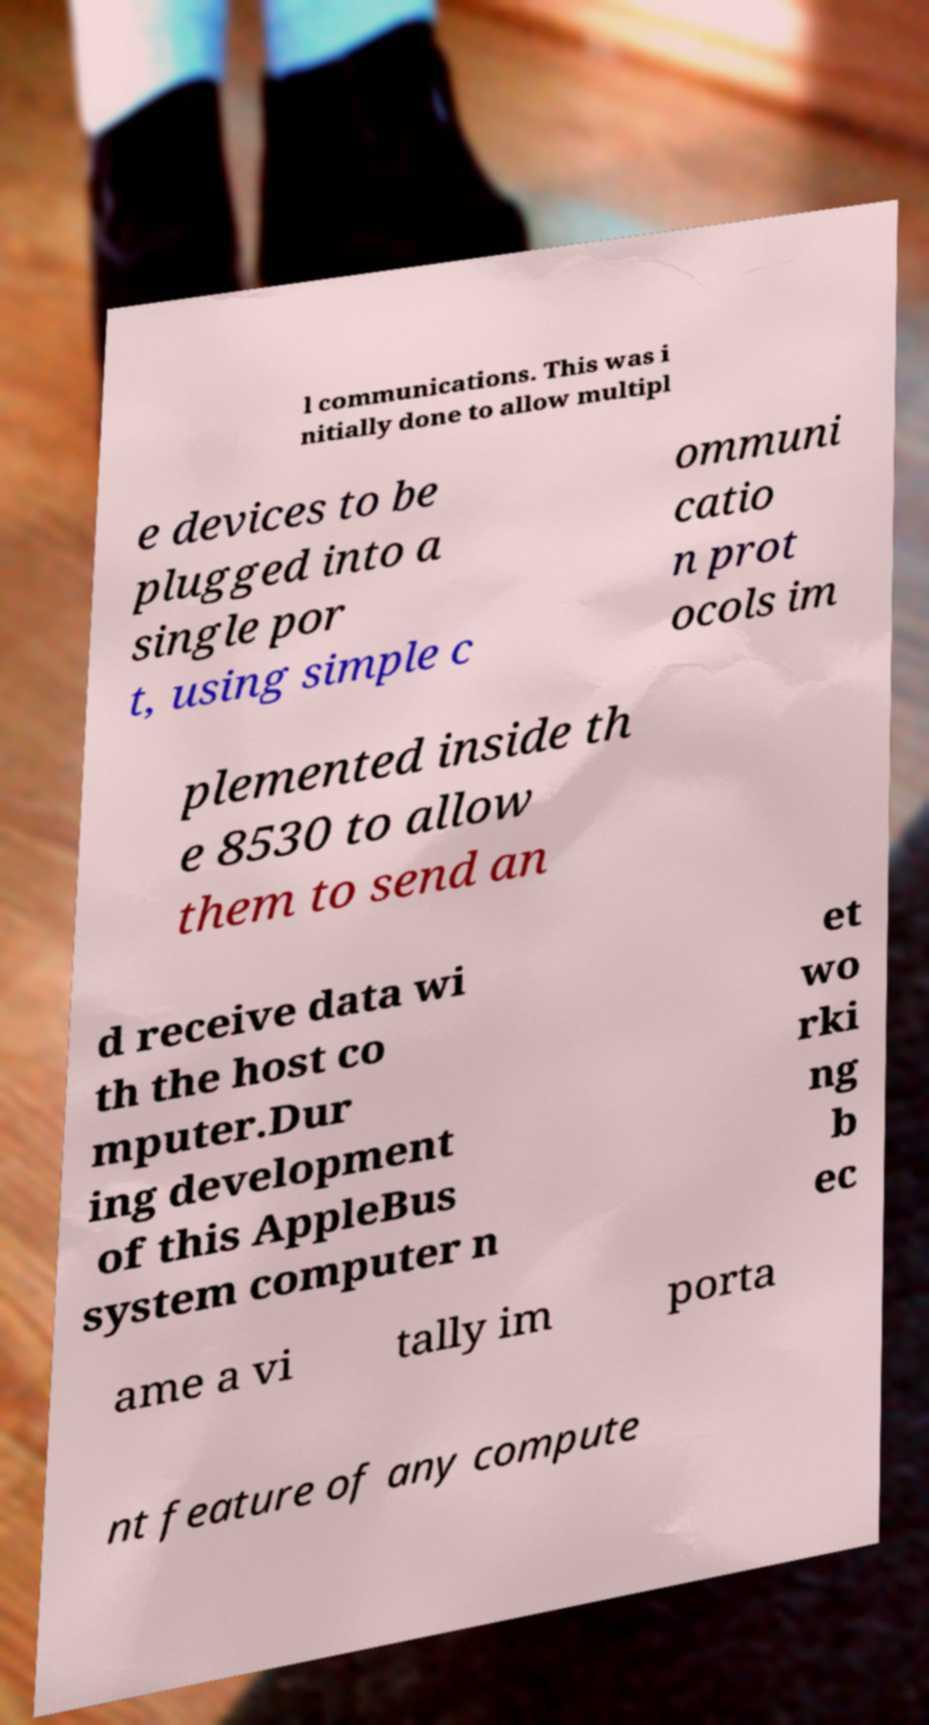Please identify and transcribe the text found in this image. l communications. This was i nitially done to allow multipl e devices to be plugged into a single por t, using simple c ommuni catio n prot ocols im plemented inside th e 8530 to allow them to send an d receive data wi th the host co mputer.Dur ing development of this AppleBus system computer n et wo rki ng b ec ame a vi tally im porta nt feature of any compute 